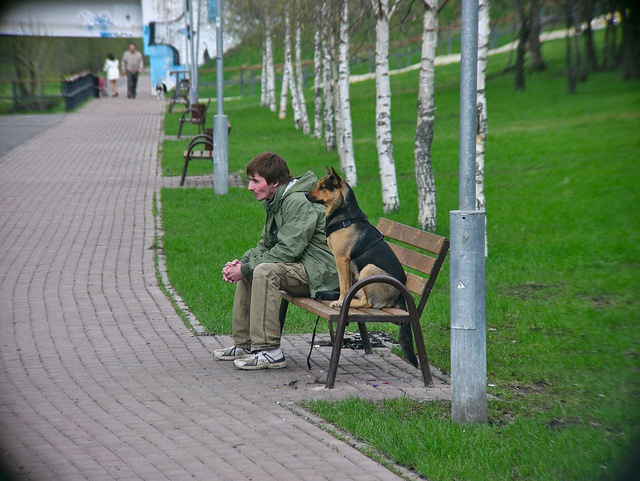Describe the objects in this image and their specific colors. I can see people in black, gray, and darkgray tones, bench in black and gray tones, dog in black, gray, and tan tones, bench in black, gray, darkgray, and darkgreen tones, and people in black, darkgray, and gray tones in this image. 